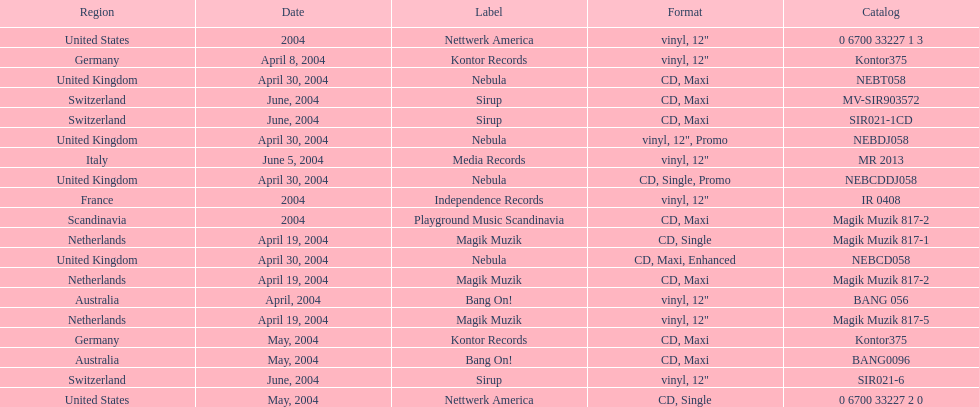What region is above australia? Germany. 